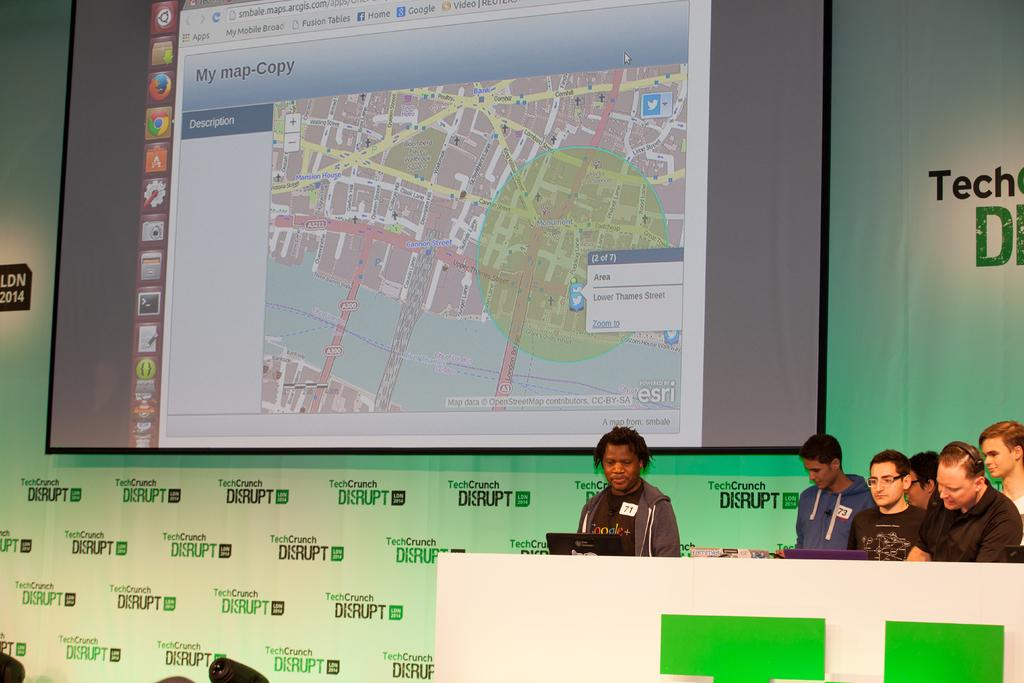What are the people in the image doing near the desk? There are people sitting near a desk in the image. What device is one of the people using? A person is watching a laptop. What additional equipment is present in the image? There is a projector screen in the image. Can you see any waves in the image? There are no waves present in the image. How many pigs are visible on the projector screen? There are no pigs depicted on the projector screen; it is not mentioned in the facts. 